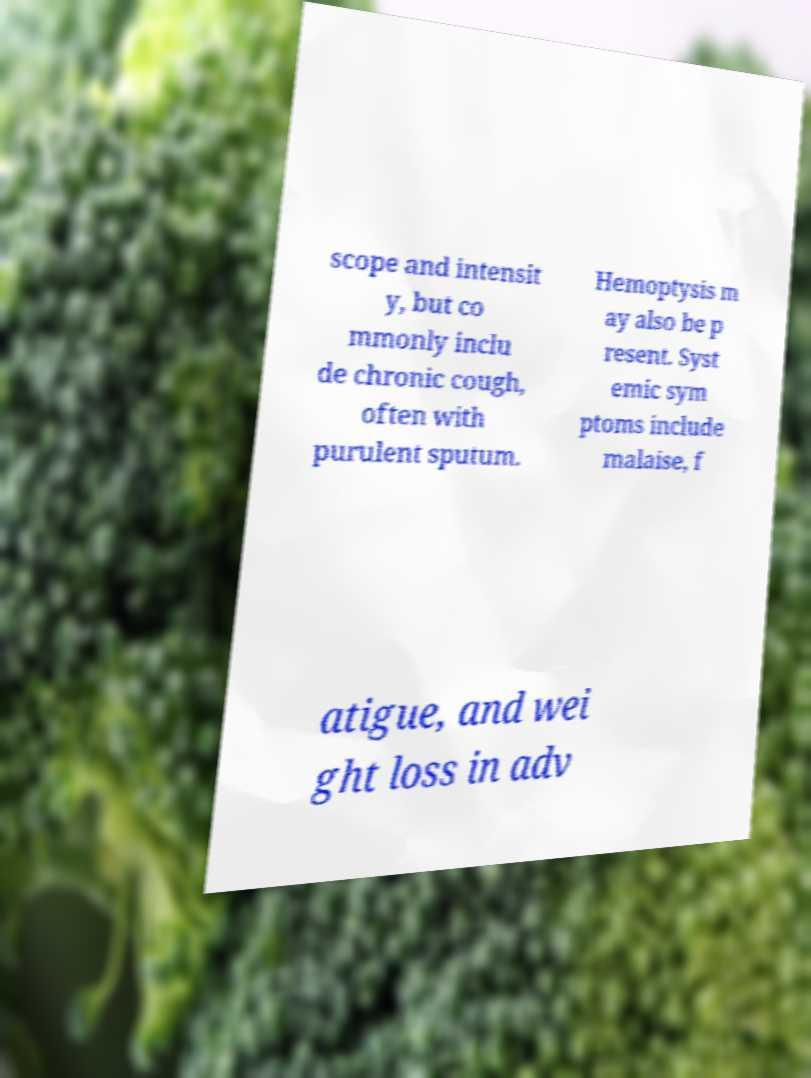What messages or text are displayed in this image? I need them in a readable, typed format. scope and intensit y, but co mmonly inclu de chronic cough, often with purulent sputum. Hemoptysis m ay also be p resent. Syst emic sym ptoms include malaise, f atigue, and wei ght loss in adv 